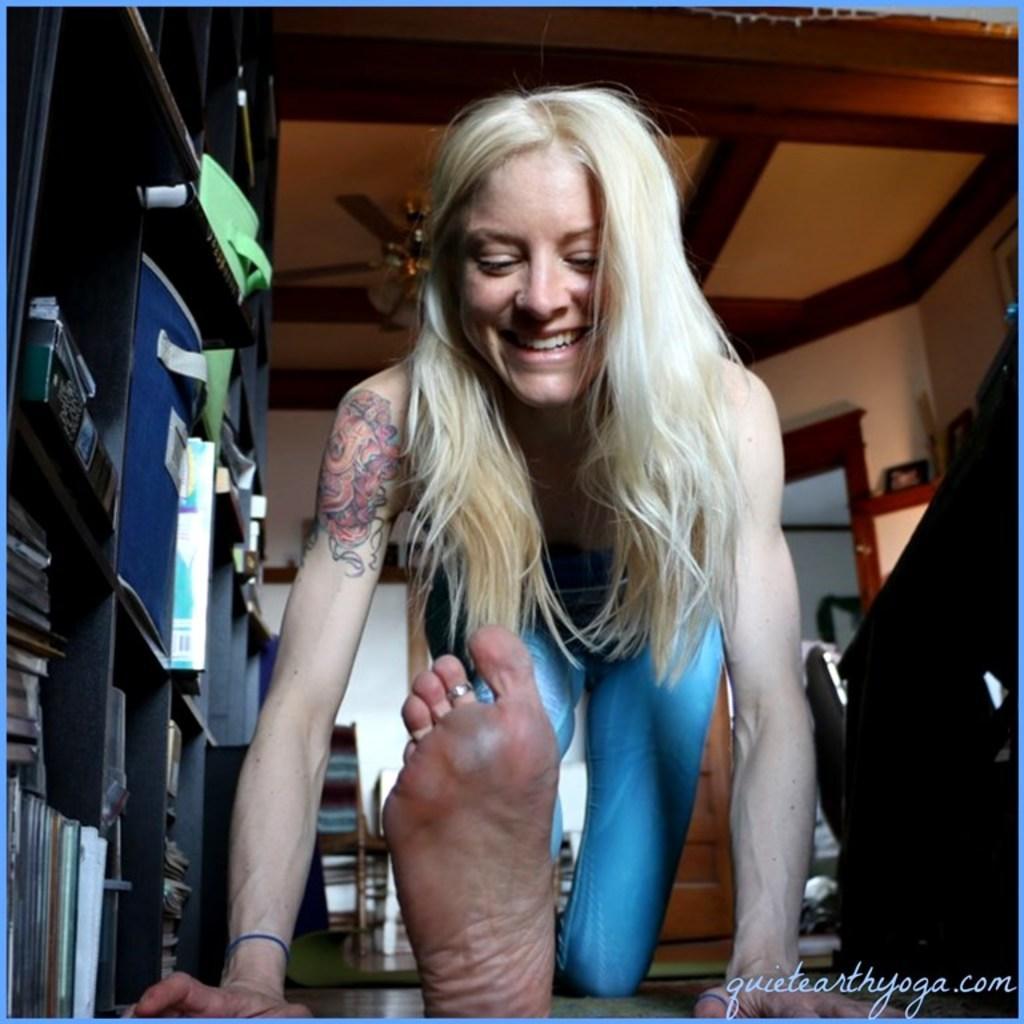In one or two sentences, can you explain what this image depicts? This is the picture of a room. In this image there is a woman sitting on knees and she is smiling. On the left side of the image there are books and objects in the cupboard. On the right side of the image there is a table. At the back there is a chair and door. At the top there is fan and there are frames on the wall. At the bottom there are mats. 